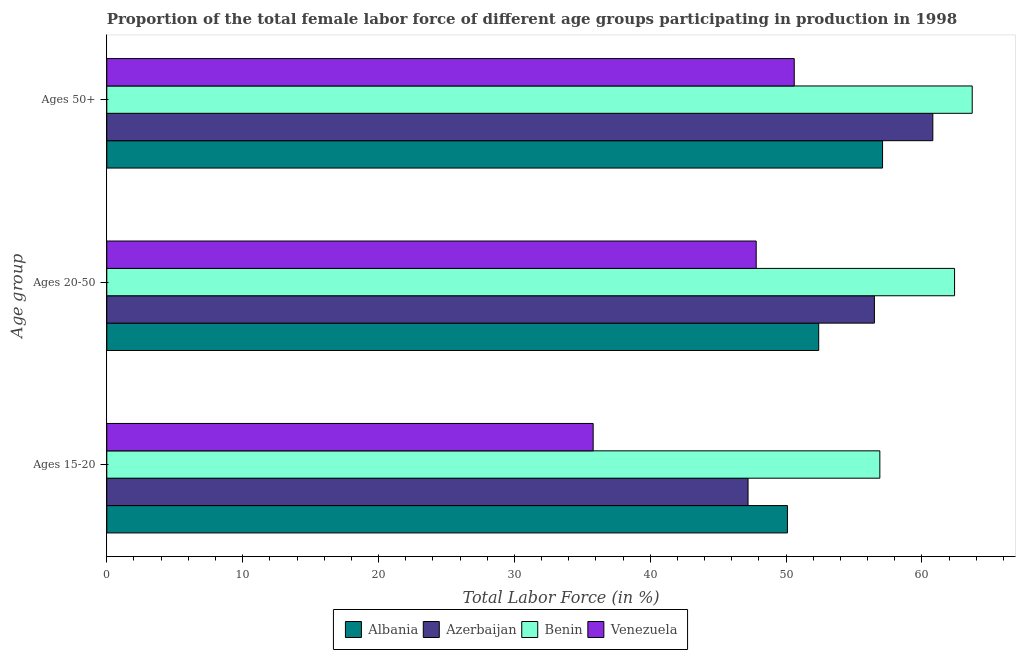How many different coloured bars are there?
Provide a short and direct response. 4. How many groups of bars are there?
Your response must be concise. 3. Are the number of bars per tick equal to the number of legend labels?
Offer a very short reply. Yes. How many bars are there on the 3rd tick from the bottom?
Offer a terse response. 4. What is the label of the 3rd group of bars from the top?
Your answer should be compact. Ages 15-20. What is the percentage of female labor force within the age group 20-50 in Venezuela?
Your answer should be very brief. 47.8. Across all countries, what is the maximum percentage of female labor force within the age group 20-50?
Provide a short and direct response. 62.4. Across all countries, what is the minimum percentage of female labor force above age 50?
Your answer should be compact. 50.6. In which country was the percentage of female labor force within the age group 20-50 maximum?
Offer a very short reply. Benin. In which country was the percentage of female labor force within the age group 20-50 minimum?
Your response must be concise. Venezuela. What is the total percentage of female labor force within the age group 20-50 in the graph?
Keep it short and to the point. 219.1. What is the difference between the percentage of female labor force within the age group 15-20 in Azerbaijan and that in Venezuela?
Offer a terse response. 11.4. What is the difference between the percentage of female labor force within the age group 15-20 in Benin and the percentage of female labor force within the age group 20-50 in Albania?
Offer a terse response. 4.5. What is the average percentage of female labor force within the age group 20-50 per country?
Provide a short and direct response. 54.78. What is the difference between the percentage of female labor force within the age group 15-20 and percentage of female labor force above age 50 in Azerbaijan?
Ensure brevity in your answer.  -13.6. What is the ratio of the percentage of female labor force within the age group 15-20 in Albania to that in Benin?
Give a very brief answer. 0.88. Is the percentage of female labor force above age 50 in Venezuela less than that in Azerbaijan?
Provide a succinct answer. Yes. Is the difference between the percentage of female labor force within the age group 15-20 in Benin and Albania greater than the difference between the percentage of female labor force within the age group 20-50 in Benin and Albania?
Your answer should be compact. No. What is the difference between the highest and the second highest percentage of female labor force within the age group 15-20?
Your answer should be compact. 6.8. What is the difference between the highest and the lowest percentage of female labor force within the age group 20-50?
Provide a succinct answer. 14.6. In how many countries, is the percentage of female labor force above age 50 greater than the average percentage of female labor force above age 50 taken over all countries?
Make the answer very short. 2. What does the 2nd bar from the top in Ages 50+ represents?
Your response must be concise. Benin. What does the 3rd bar from the bottom in Ages 20-50 represents?
Give a very brief answer. Benin. How many bars are there?
Offer a very short reply. 12. Are the values on the major ticks of X-axis written in scientific E-notation?
Make the answer very short. No. Does the graph contain any zero values?
Offer a terse response. No. Where does the legend appear in the graph?
Provide a succinct answer. Bottom center. How many legend labels are there?
Keep it short and to the point. 4. What is the title of the graph?
Your answer should be very brief. Proportion of the total female labor force of different age groups participating in production in 1998. What is the label or title of the Y-axis?
Offer a very short reply. Age group. What is the Total Labor Force (in %) in Albania in Ages 15-20?
Keep it short and to the point. 50.1. What is the Total Labor Force (in %) in Azerbaijan in Ages 15-20?
Provide a short and direct response. 47.2. What is the Total Labor Force (in %) of Benin in Ages 15-20?
Ensure brevity in your answer.  56.9. What is the Total Labor Force (in %) of Venezuela in Ages 15-20?
Provide a succinct answer. 35.8. What is the Total Labor Force (in %) in Albania in Ages 20-50?
Provide a short and direct response. 52.4. What is the Total Labor Force (in %) of Azerbaijan in Ages 20-50?
Your answer should be very brief. 56.5. What is the Total Labor Force (in %) of Benin in Ages 20-50?
Ensure brevity in your answer.  62.4. What is the Total Labor Force (in %) of Venezuela in Ages 20-50?
Offer a terse response. 47.8. What is the Total Labor Force (in %) in Albania in Ages 50+?
Your response must be concise. 57.1. What is the Total Labor Force (in %) of Azerbaijan in Ages 50+?
Keep it short and to the point. 60.8. What is the Total Labor Force (in %) of Benin in Ages 50+?
Make the answer very short. 63.7. What is the Total Labor Force (in %) in Venezuela in Ages 50+?
Offer a very short reply. 50.6. Across all Age group, what is the maximum Total Labor Force (in %) in Albania?
Offer a terse response. 57.1. Across all Age group, what is the maximum Total Labor Force (in %) in Azerbaijan?
Your response must be concise. 60.8. Across all Age group, what is the maximum Total Labor Force (in %) of Benin?
Make the answer very short. 63.7. Across all Age group, what is the maximum Total Labor Force (in %) of Venezuela?
Give a very brief answer. 50.6. Across all Age group, what is the minimum Total Labor Force (in %) of Albania?
Your response must be concise. 50.1. Across all Age group, what is the minimum Total Labor Force (in %) in Azerbaijan?
Your response must be concise. 47.2. Across all Age group, what is the minimum Total Labor Force (in %) in Benin?
Keep it short and to the point. 56.9. Across all Age group, what is the minimum Total Labor Force (in %) of Venezuela?
Make the answer very short. 35.8. What is the total Total Labor Force (in %) in Albania in the graph?
Your answer should be compact. 159.6. What is the total Total Labor Force (in %) of Azerbaijan in the graph?
Make the answer very short. 164.5. What is the total Total Labor Force (in %) of Benin in the graph?
Make the answer very short. 183. What is the total Total Labor Force (in %) of Venezuela in the graph?
Your answer should be very brief. 134.2. What is the difference between the Total Labor Force (in %) of Azerbaijan in Ages 15-20 and that in Ages 20-50?
Give a very brief answer. -9.3. What is the difference between the Total Labor Force (in %) in Benin in Ages 15-20 and that in Ages 20-50?
Keep it short and to the point. -5.5. What is the difference between the Total Labor Force (in %) in Venezuela in Ages 15-20 and that in Ages 20-50?
Ensure brevity in your answer.  -12. What is the difference between the Total Labor Force (in %) of Azerbaijan in Ages 15-20 and that in Ages 50+?
Keep it short and to the point. -13.6. What is the difference between the Total Labor Force (in %) of Venezuela in Ages 15-20 and that in Ages 50+?
Your response must be concise. -14.8. What is the difference between the Total Labor Force (in %) of Albania in Ages 20-50 and that in Ages 50+?
Give a very brief answer. -4.7. What is the difference between the Total Labor Force (in %) in Azerbaijan in Ages 20-50 and that in Ages 50+?
Offer a very short reply. -4.3. What is the difference between the Total Labor Force (in %) of Venezuela in Ages 20-50 and that in Ages 50+?
Ensure brevity in your answer.  -2.8. What is the difference between the Total Labor Force (in %) of Albania in Ages 15-20 and the Total Labor Force (in %) of Azerbaijan in Ages 20-50?
Offer a very short reply. -6.4. What is the difference between the Total Labor Force (in %) of Albania in Ages 15-20 and the Total Labor Force (in %) of Benin in Ages 20-50?
Your response must be concise. -12.3. What is the difference between the Total Labor Force (in %) of Azerbaijan in Ages 15-20 and the Total Labor Force (in %) of Benin in Ages 20-50?
Keep it short and to the point. -15.2. What is the difference between the Total Labor Force (in %) of Azerbaijan in Ages 15-20 and the Total Labor Force (in %) of Venezuela in Ages 20-50?
Your answer should be compact. -0.6. What is the difference between the Total Labor Force (in %) of Azerbaijan in Ages 15-20 and the Total Labor Force (in %) of Benin in Ages 50+?
Your answer should be compact. -16.5. What is the difference between the Total Labor Force (in %) in Azerbaijan in Ages 15-20 and the Total Labor Force (in %) in Venezuela in Ages 50+?
Make the answer very short. -3.4. What is the difference between the Total Labor Force (in %) in Albania in Ages 20-50 and the Total Labor Force (in %) in Benin in Ages 50+?
Offer a very short reply. -11.3. What is the difference between the Total Labor Force (in %) in Albania in Ages 20-50 and the Total Labor Force (in %) in Venezuela in Ages 50+?
Offer a terse response. 1.8. What is the average Total Labor Force (in %) of Albania per Age group?
Make the answer very short. 53.2. What is the average Total Labor Force (in %) of Azerbaijan per Age group?
Make the answer very short. 54.83. What is the average Total Labor Force (in %) of Venezuela per Age group?
Provide a succinct answer. 44.73. What is the difference between the Total Labor Force (in %) in Albania and Total Labor Force (in %) in Azerbaijan in Ages 15-20?
Keep it short and to the point. 2.9. What is the difference between the Total Labor Force (in %) of Albania and Total Labor Force (in %) of Venezuela in Ages 15-20?
Your response must be concise. 14.3. What is the difference between the Total Labor Force (in %) of Azerbaijan and Total Labor Force (in %) of Benin in Ages 15-20?
Give a very brief answer. -9.7. What is the difference between the Total Labor Force (in %) of Benin and Total Labor Force (in %) of Venezuela in Ages 15-20?
Your response must be concise. 21.1. What is the difference between the Total Labor Force (in %) in Albania and Total Labor Force (in %) in Azerbaijan in Ages 20-50?
Offer a very short reply. -4.1. What is the difference between the Total Labor Force (in %) in Albania and Total Labor Force (in %) in Benin in Ages 20-50?
Make the answer very short. -10. What is the difference between the Total Labor Force (in %) in Albania and Total Labor Force (in %) in Venezuela in Ages 20-50?
Give a very brief answer. 4.6. What is the difference between the Total Labor Force (in %) of Albania and Total Labor Force (in %) of Azerbaijan in Ages 50+?
Give a very brief answer. -3.7. What is the difference between the Total Labor Force (in %) of Albania and Total Labor Force (in %) of Benin in Ages 50+?
Your answer should be very brief. -6.6. What is the difference between the Total Labor Force (in %) of Azerbaijan and Total Labor Force (in %) of Venezuela in Ages 50+?
Provide a short and direct response. 10.2. What is the ratio of the Total Labor Force (in %) of Albania in Ages 15-20 to that in Ages 20-50?
Provide a short and direct response. 0.96. What is the ratio of the Total Labor Force (in %) in Azerbaijan in Ages 15-20 to that in Ages 20-50?
Ensure brevity in your answer.  0.84. What is the ratio of the Total Labor Force (in %) of Benin in Ages 15-20 to that in Ages 20-50?
Keep it short and to the point. 0.91. What is the ratio of the Total Labor Force (in %) in Venezuela in Ages 15-20 to that in Ages 20-50?
Make the answer very short. 0.75. What is the ratio of the Total Labor Force (in %) of Albania in Ages 15-20 to that in Ages 50+?
Give a very brief answer. 0.88. What is the ratio of the Total Labor Force (in %) in Azerbaijan in Ages 15-20 to that in Ages 50+?
Give a very brief answer. 0.78. What is the ratio of the Total Labor Force (in %) in Benin in Ages 15-20 to that in Ages 50+?
Provide a succinct answer. 0.89. What is the ratio of the Total Labor Force (in %) in Venezuela in Ages 15-20 to that in Ages 50+?
Your answer should be very brief. 0.71. What is the ratio of the Total Labor Force (in %) in Albania in Ages 20-50 to that in Ages 50+?
Give a very brief answer. 0.92. What is the ratio of the Total Labor Force (in %) of Azerbaijan in Ages 20-50 to that in Ages 50+?
Offer a very short reply. 0.93. What is the ratio of the Total Labor Force (in %) in Benin in Ages 20-50 to that in Ages 50+?
Provide a short and direct response. 0.98. What is the ratio of the Total Labor Force (in %) of Venezuela in Ages 20-50 to that in Ages 50+?
Offer a terse response. 0.94. What is the difference between the highest and the second highest Total Labor Force (in %) of Azerbaijan?
Offer a terse response. 4.3. What is the difference between the highest and the second highest Total Labor Force (in %) in Benin?
Offer a very short reply. 1.3. What is the difference between the highest and the second highest Total Labor Force (in %) of Venezuela?
Provide a succinct answer. 2.8. What is the difference between the highest and the lowest Total Labor Force (in %) in Benin?
Give a very brief answer. 6.8. What is the difference between the highest and the lowest Total Labor Force (in %) in Venezuela?
Provide a short and direct response. 14.8. 